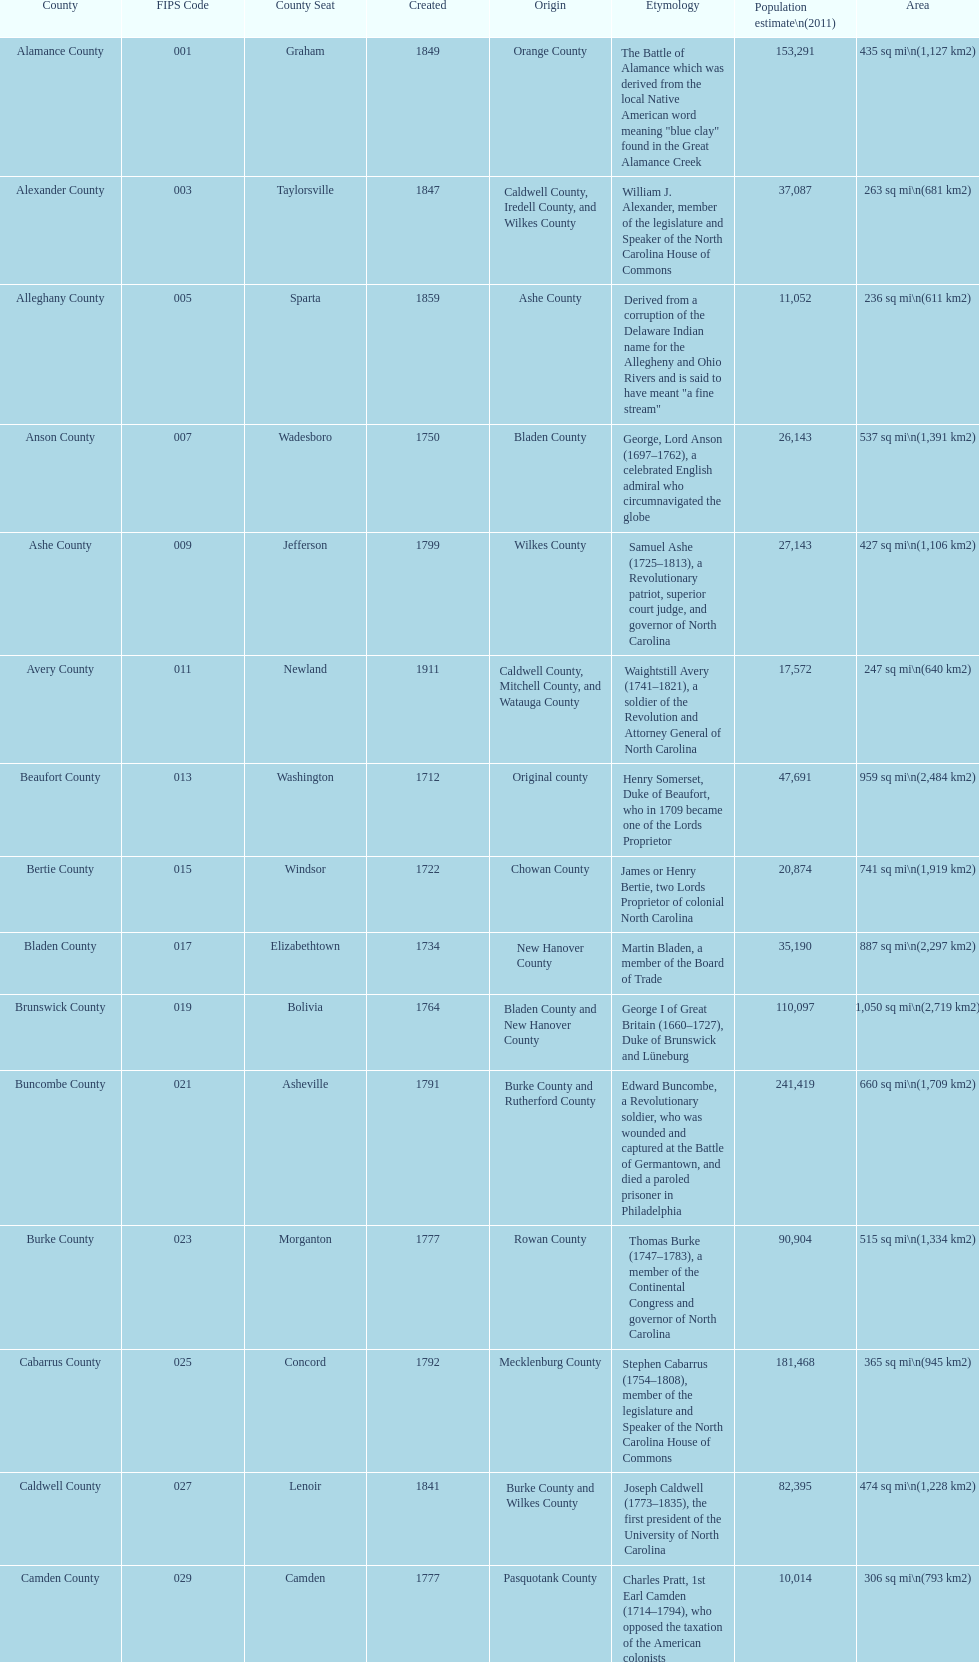Other than mecklenburg which county has the largest population? Wake County. 